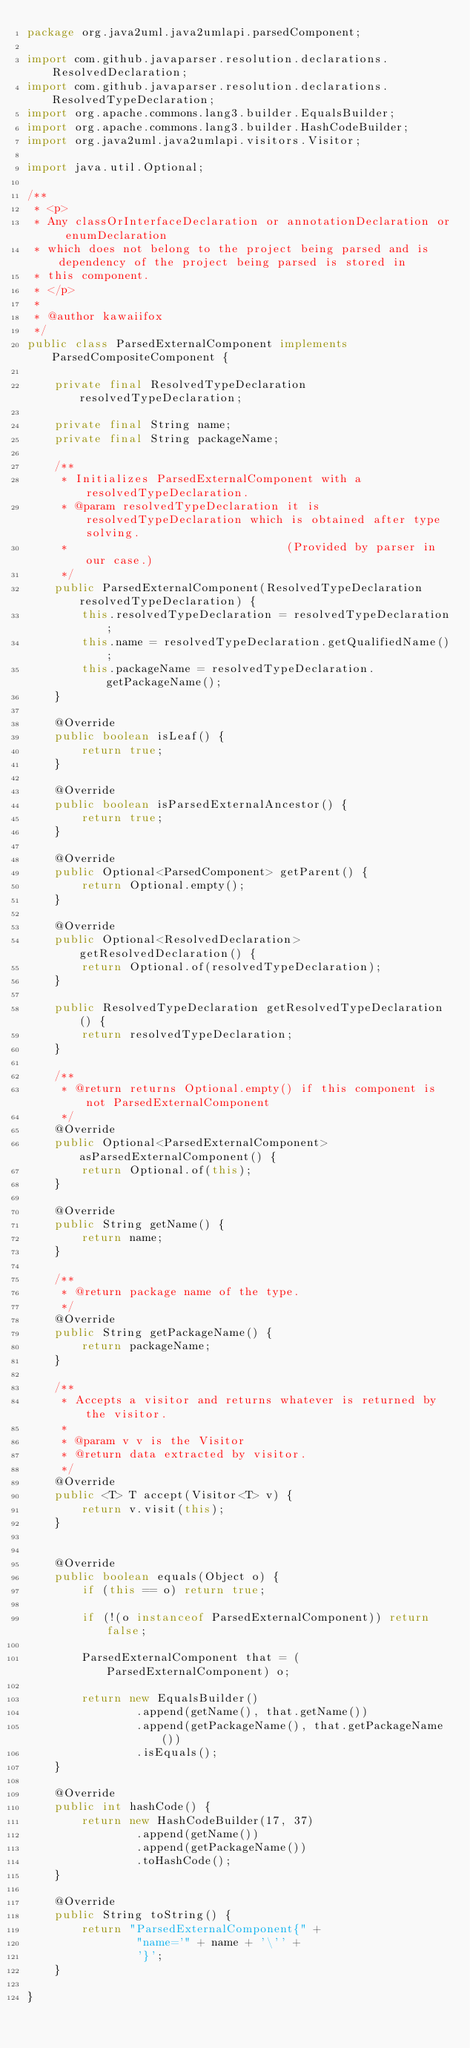<code> <loc_0><loc_0><loc_500><loc_500><_Java_>package org.java2uml.java2umlapi.parsedComponent;

import com.github.javaparser.resolution.declarations.ResolvedDeclaration;
import com.github.javaparser.resolution.declarations.ResolvedTypeDeclaration;
import org.apache.commons.lang3.builder.EqualsBuilder;
import org.apache.commons.lang3.builder.HashCodeBuilder;
import org.java2uml.java2umlapi.visitors.Visitor;

import java.util.Optional;

/**
 * <p>
 * Any classOrInterfaceDeclaration or annotationDeclaration or enumDeclaration
 * which does not belong to the project being parsed and is dependency of the project being parsed is stored in
 * this component.
 * </p>
 *
 * @author kawaiifox
 */
public class ParsedExternalComponent implements ParsedCompositeComponent {

    private final ResolvedTypeDeclaration resolvedTypeDeclaration;

    private final String name;
    private final String packageName;

    /**
     * Initializes ParsedExternalComponent with a resolvedTypeDeclaration.
     * @param resolvedTypeDeclaration it is resolvedTypeDeclaration which is obtained after type solving.
     *                                (Provided by parser in our case.)
     */
    public ParsedExternalComponent(ResolvedTypeDeclaration resolvedTypeDeclaration) {
        this.resolvedTypeDeclaration = resolvedTypeDeclaration;
        this.name = resolvedTypeDeclaration.getQualifiedName();
        this.packageName = resolvedTypeDeclaration.getPackageName();
    }

    @Override
    public boolean isLeaf() {
        return true;
    }

    @Override
    public boolean isParsedExternalAncestor() {
        return true;
    }

    @Override
    public Optional<ParsedComponent> getParent() {
        return Optional.empty();
    }

    @Override
    public Optional<ResolvedDeclaration> getResolvedDeclaration() {
        return Optional.of(resolvedTypeDeclaration);
    }

    public ResolvedTypeDeclaration getResolvedTypeDeclaration() {
        return resolvedTypeDeclaration;
    }

    /**
     * @return returns Optional.empty() if this component is not ParsedExternalComponent
     */
    @Override
    public Optional<ParsedExternalComponent> asParsedExternalComponent() {
        return Optional.of(this);
    }

    @Override
    public String getName() {
        return name;
    }

    /**
     * @return package name of the type.
     */
    @Override
    public String getPackageName() {
        return packageName;
    }

    /**
     * Accepts a visitor and returns whatever is returned by the visitor.
     *
     * @param v v is the Visitor
     * @return data extracted by visitor.
     */
    @Override
    public <T> T accept(Visitor<T> v) {
        return v.visit(this);
    }


    @Override
    public boolean equals(Object o) {
        if (this == o) return true;

        if (!(o instanceof ParsedExternalComponent)) return false;

        ParsedExternalComponent that = (ParsedExternalComponent) o;

        return new EqualsBuilder()
                .append(getName(), that.getName())
                .append(getPackageName(), that.getPackageName())
                .isEquals();
    }

    @Override
    public int hashCode() {
        return new HashCodeBuilder(17, 37)
                .append(getName())
                .append(getPackageName())
                .toHashCode();
    }

    @Override
    public String toString() {
        return "ParsedExternalComponent{" +
                "name='" + name + '\'' +
                '}';
    }

}
</code> 